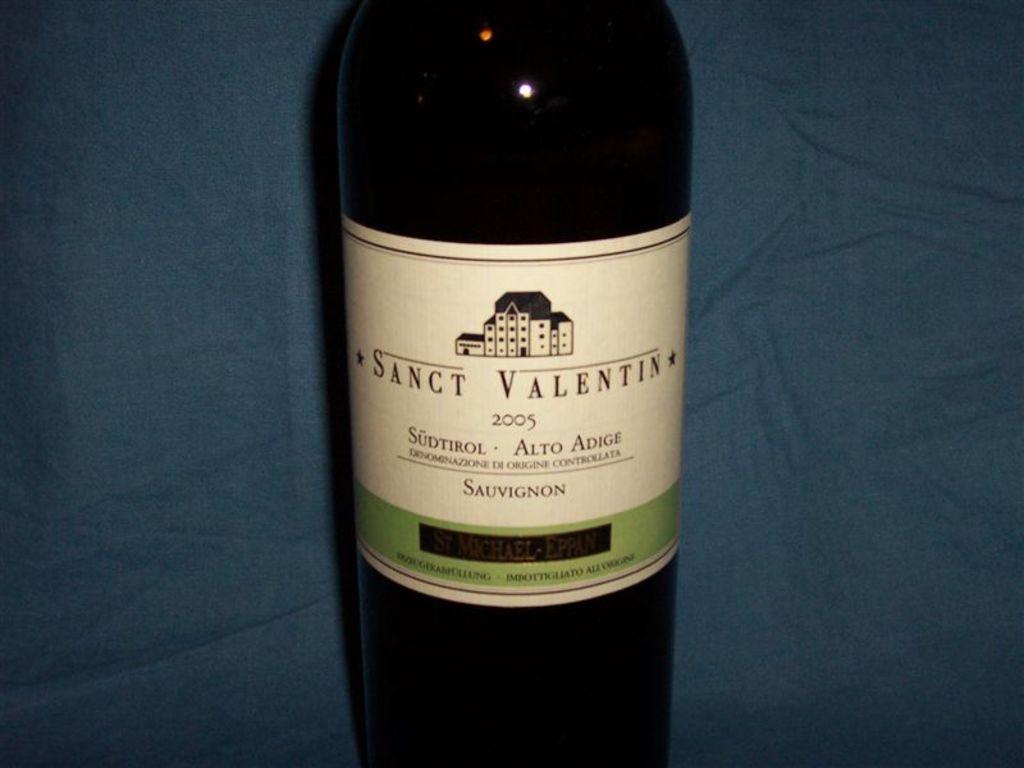What brand is this wine?
Offer a terse response. Sanct valentin. 